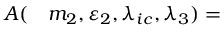<formula> <loc_0><loc_0><loc_500><loc_500>\begin{array} { r l } { A ( } & m _ { 2 } , \varepsilon _ { 2 } , \lambda _ { i c } , \lambda _ { 3 } ) = } \end{array}</formula> 